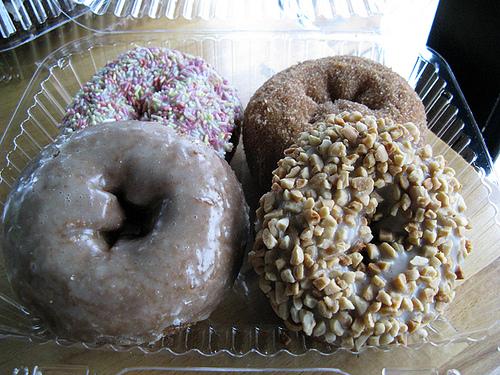Is the food sweet?
Answer briefly. Yes. Is this a good lunch?
Write a very short answer. No. Are these homemade?
Give a very brief answer. No. 